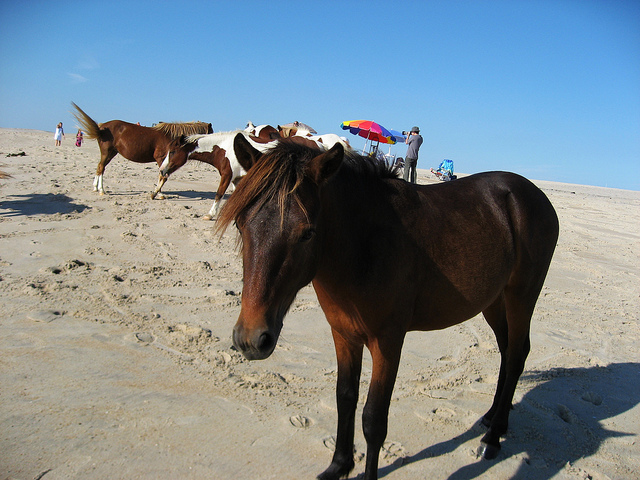How many horses are countable on the beach?
A. three
B. five
C. four
D. two
Answer with the option's letter from the given choices directly. B 